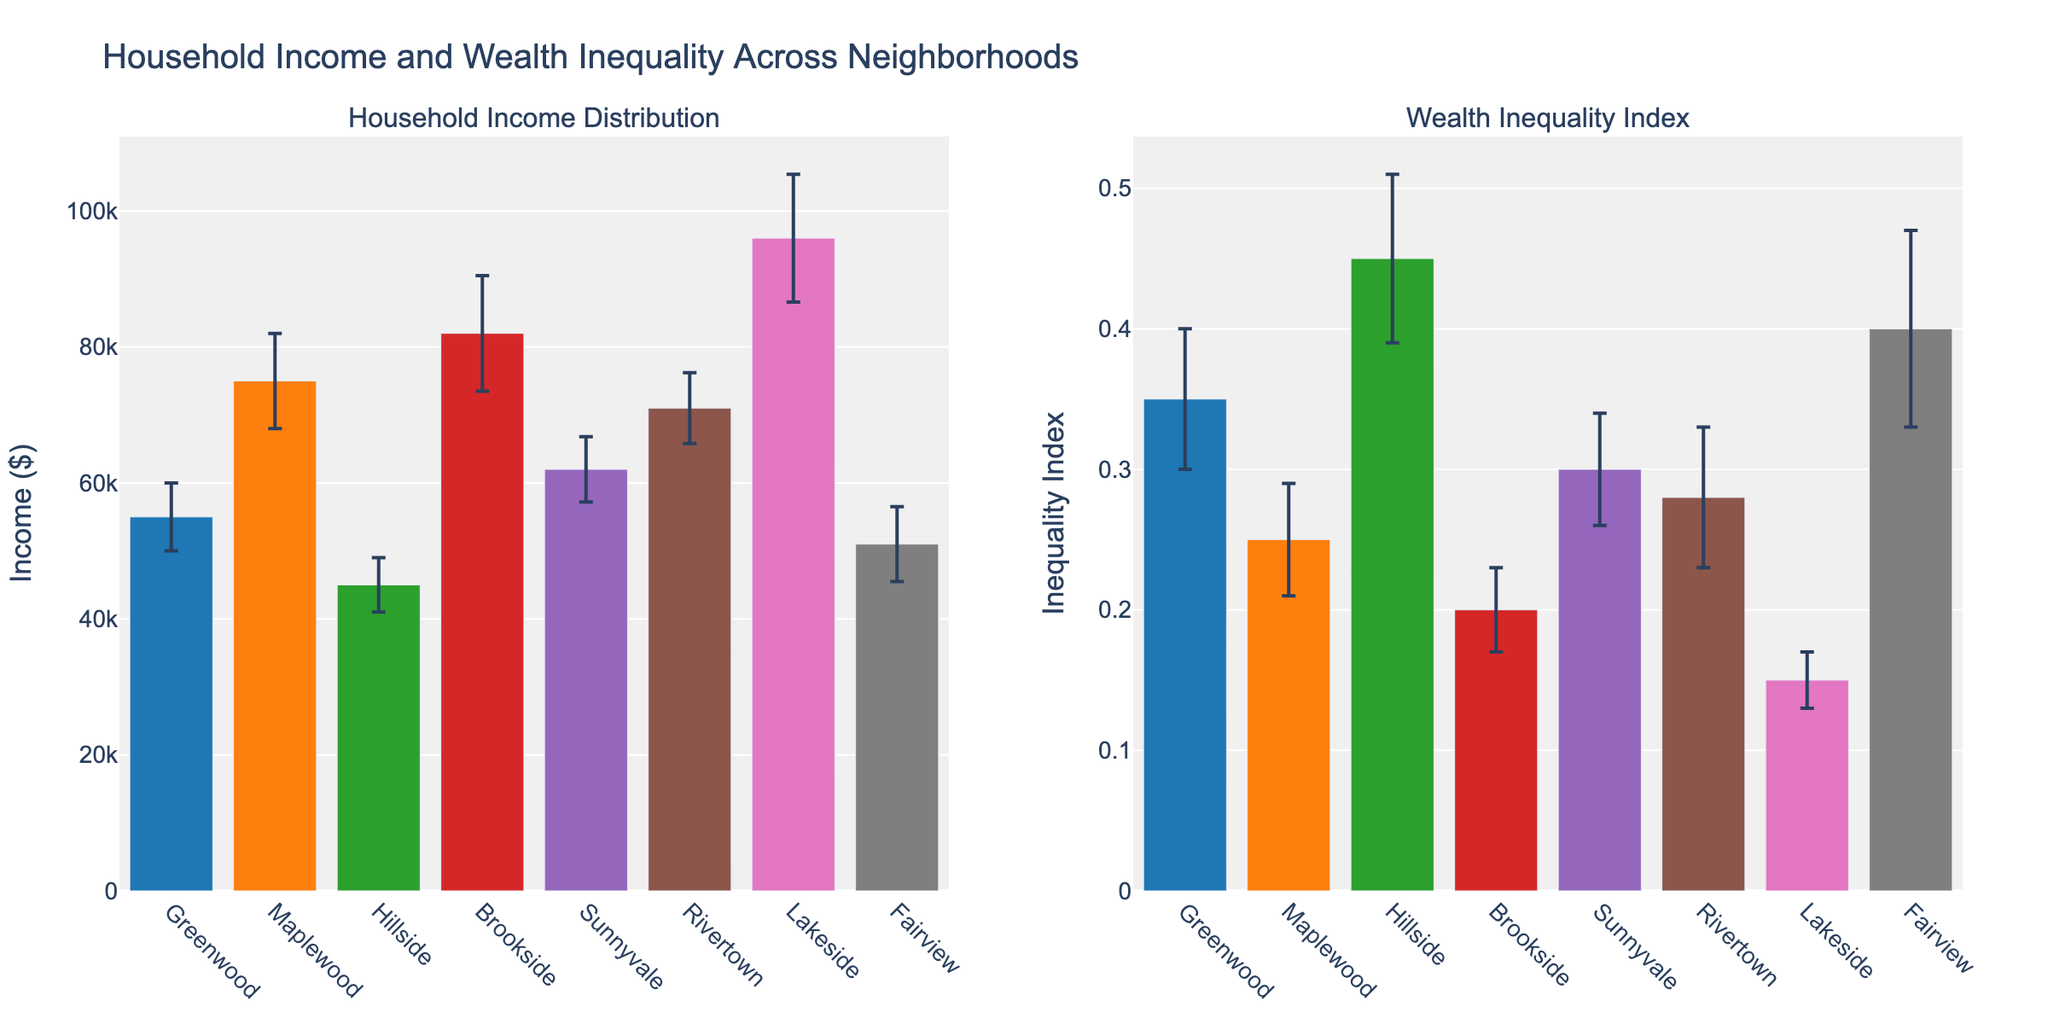what is the neighborhood with the highest mean income? The plot on the left shows the mean incomes of different neighborhoods. From these, the neighborhood with the highest bar represents the highest mean income. Lakeside has the highest bar.
Answer: Lakeside How much higher is the mean income in Brookside compared to Hillside? The bars on the left plot show the mean incomes. Brookside has a mean income of $82,000, while Hillside has $45,000. The difference is $82,000 - $45,000, which equals $37,000.
Answer: $37,000 Which neighborhood has the lowest wealth inequality index? The right plot shows the wealth inequality indices for different neighborhoods. The lowest bar corresponds to Lakeside with an index of 0.15.
Answer: Lakeside Which neighborhood has the greatest standard deviation in income? In the left plot, the error bars represent the standard deviations. The height of the error bars indicates the magnitude. Brookside’s error bar is the longest.
Answer: Brookside What is the difference in the wealth inequality index between the neighborhood with the highest and lowest indices? The right plot shows the wealth indices. Hillside has the highest index (0.45), and Lakeside has the lowest index (0.15). The difference is 0.45 - 0.15 = 0.30.
Answer: 0.30 Which neighborhoods have a mean income between $50,000 and $70,000? In the left plot, look for bars with mean incomes in the $50,000-$70,000 range. Greenwood ($55,000), Sunnyvale ($62,000), and Rivertown ($71,000) fall in this range. Rivertown is excluded as it is marginally above $70,000.
Answer: Greenwood, Sunnyvale Does the neighborhood with the highest income also have the lowest wealth inequality index? Compare the highest bar in the left plot (Lakeside) to the lowest bar in the right plot (Lakeside). Since both refer to Lakeside, the answer is yes.
Answer: Yes What’s the average mean income of all the neighborhoods? Sum the mean incomes of all neighborhoods from the left plot and divide by the number of neighborhoods: (55000 + 75000 + 45000 + 82000 + 62000 + 71000 + 96000 + 51000) / 8 = 62,375.
Answer: $62,375 Which neighborhood has a mean income closest to the overall average mean income? The overall mean income is $62,375. Compare each neighborhood’s mean income to this value. Sunnyvale has a mean income of $62,000, which is closest.
Answer: Sunnyvale 